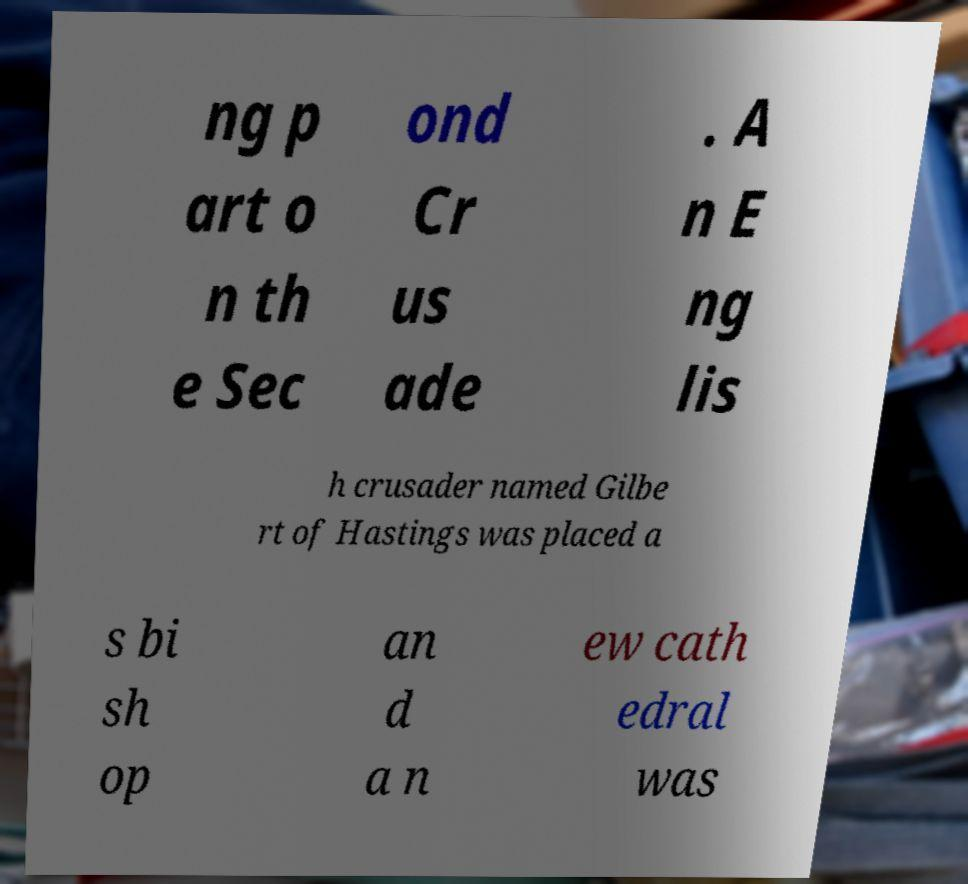Please read and relay the text visible in this image. What does it say? ng p art o n th e Sec ond Cr us ade . A n E ng lis h crusader named Gilbe rt of Hastings was placed a s bi sh op an d a n ew cath edral was 